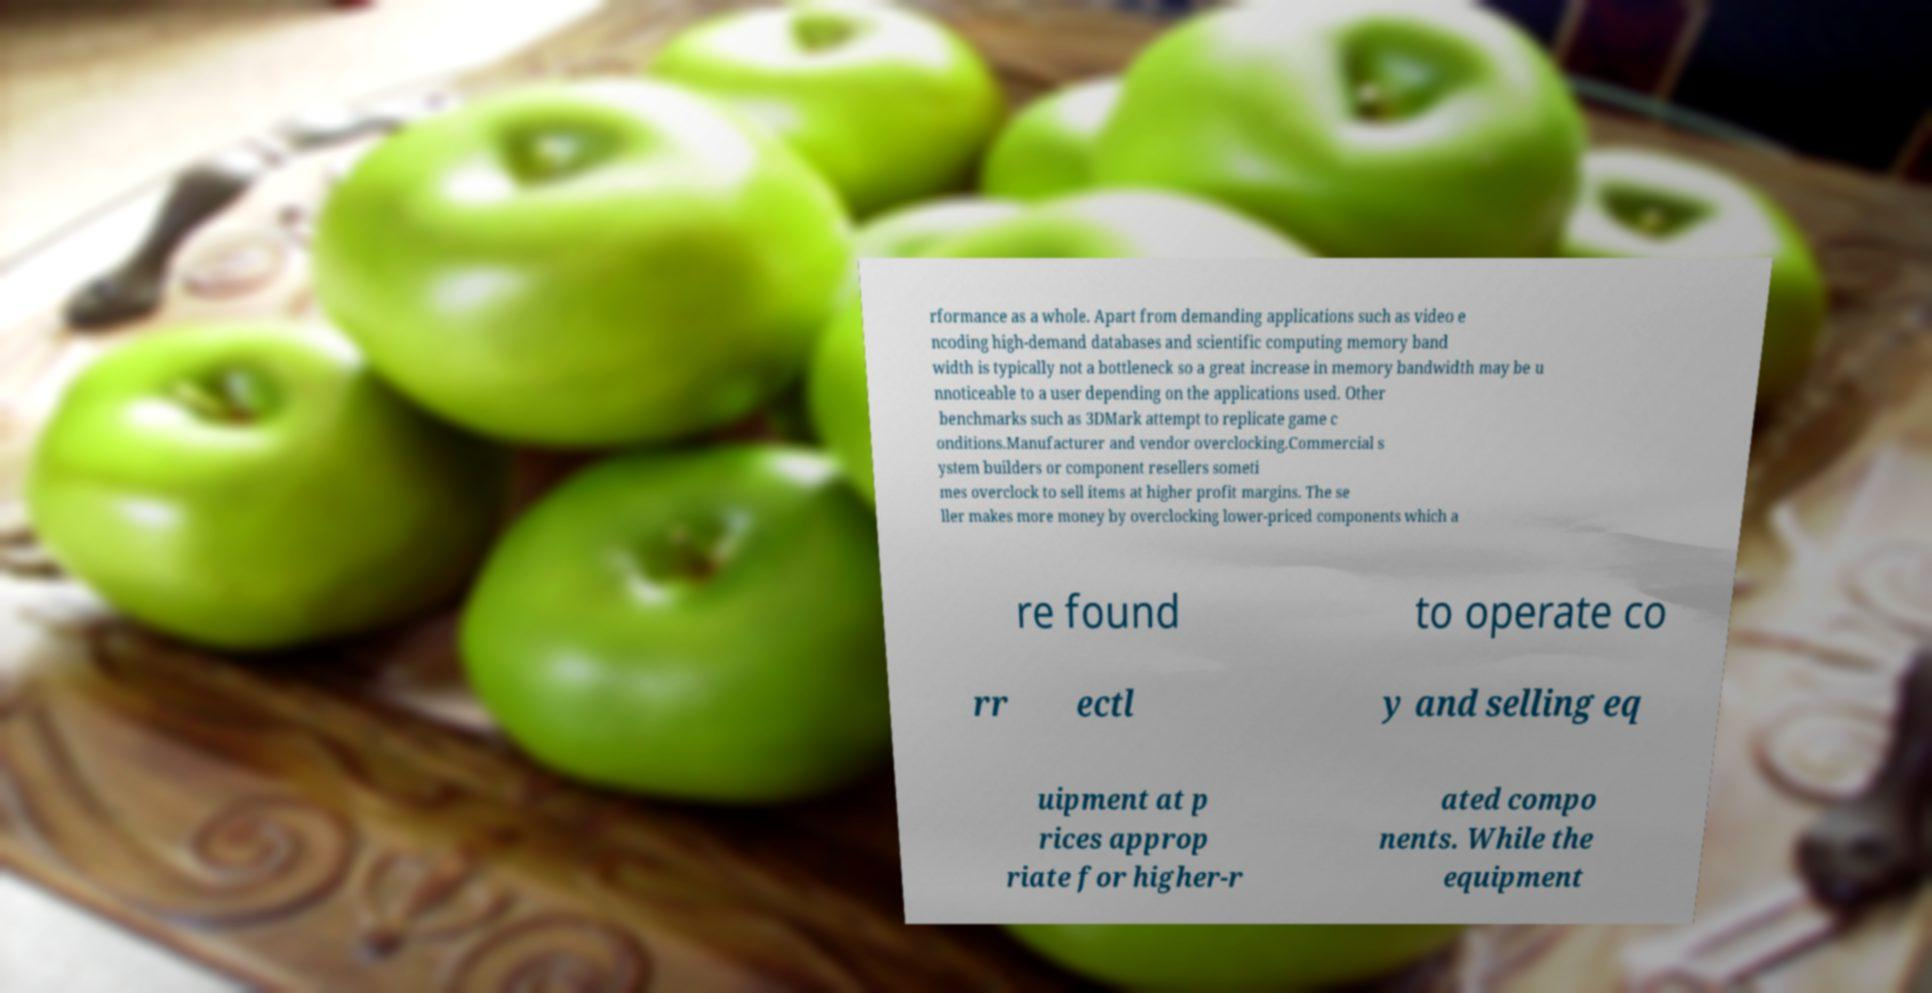I need the written content from this picture converted into text. Can you do that? rformance as a whole. Apart from demanding applications such as video e ncoding high-demand databases and scientific computing memory band width is typically not a bottleneck so a great increase in memory bandwidth may be u nnoticeable to a user depending on the applications used. Other benchmarks such as 3DMark attempt to replicate game c onditions.Manufacturer and vendor overclocking.Commercial s ystem builders or component resellers someti mes overclock to sell items at higher profit margins. The se ller makes more money by overclocking lower-priced components which a re found to operate co rr ectl y and selling eq uipment at p rices approp riate for higher-r ated compo nents. While the equipment 